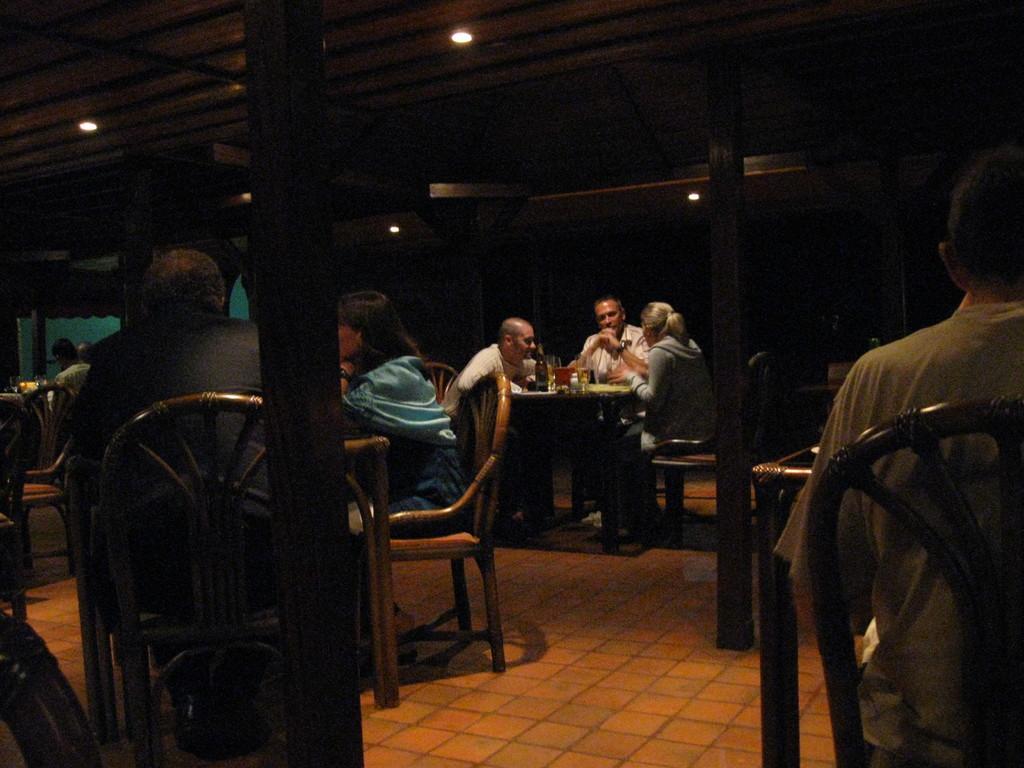Could you give a brief overview of what you see in this image? here we can see a group of people sitting on the chair, and in front there is the table and wine bottle on it and some other objects on it, and at the top there is the roof, and here are the lights. 